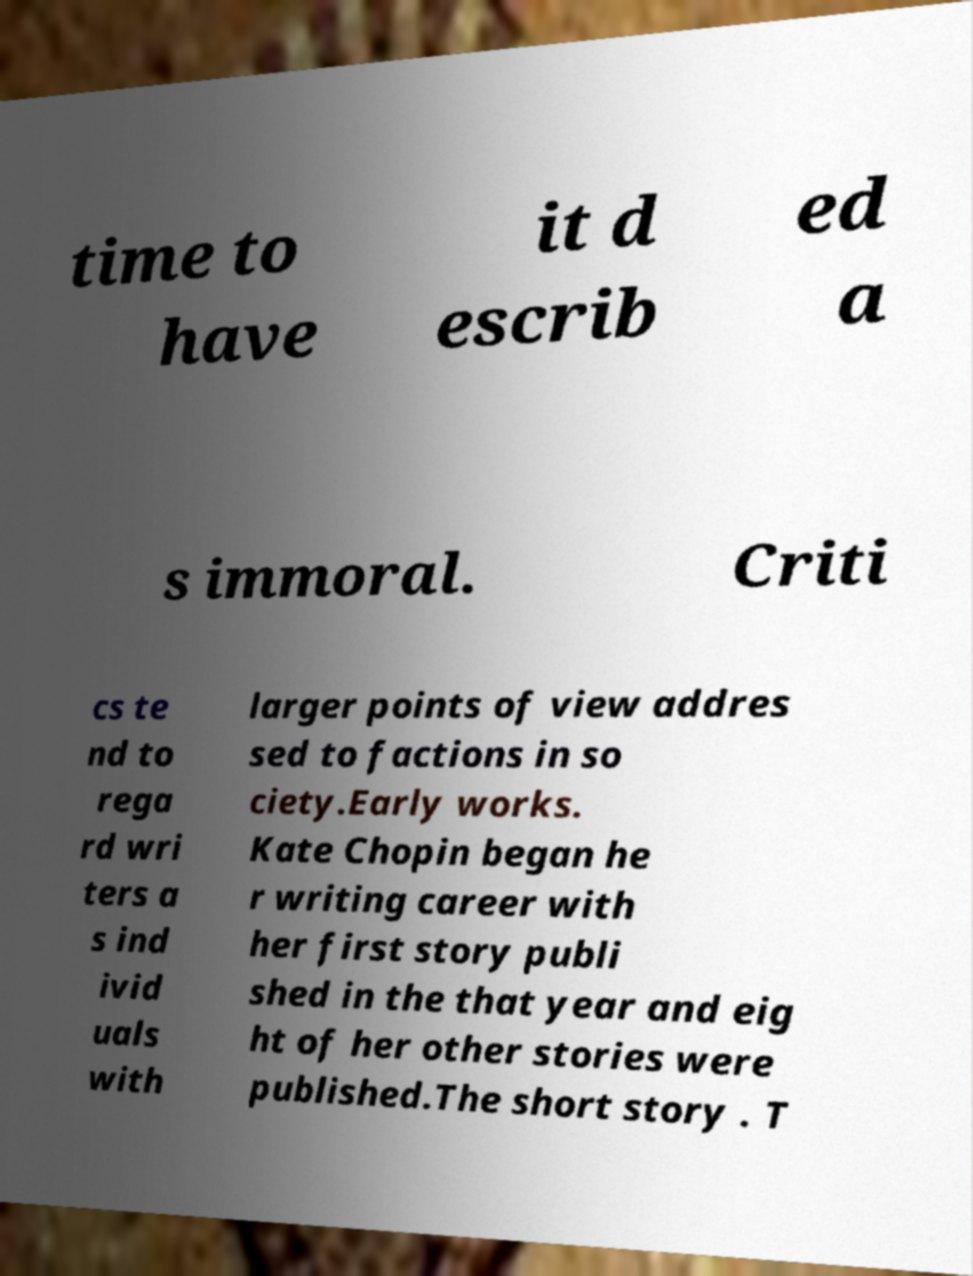What messages or text are displayed in this image? I need them in a readable, typed format. time to have it d escrib ed a s immoral. Criti cs te nd to rega rd wri ters a s ind ivid uals with larger points of view addres sed to factions in so ciety.Early works. Kate Chopin began he r writing career with her first story publi shed in the that year and eig ht of her other stories were published.The short story . T 